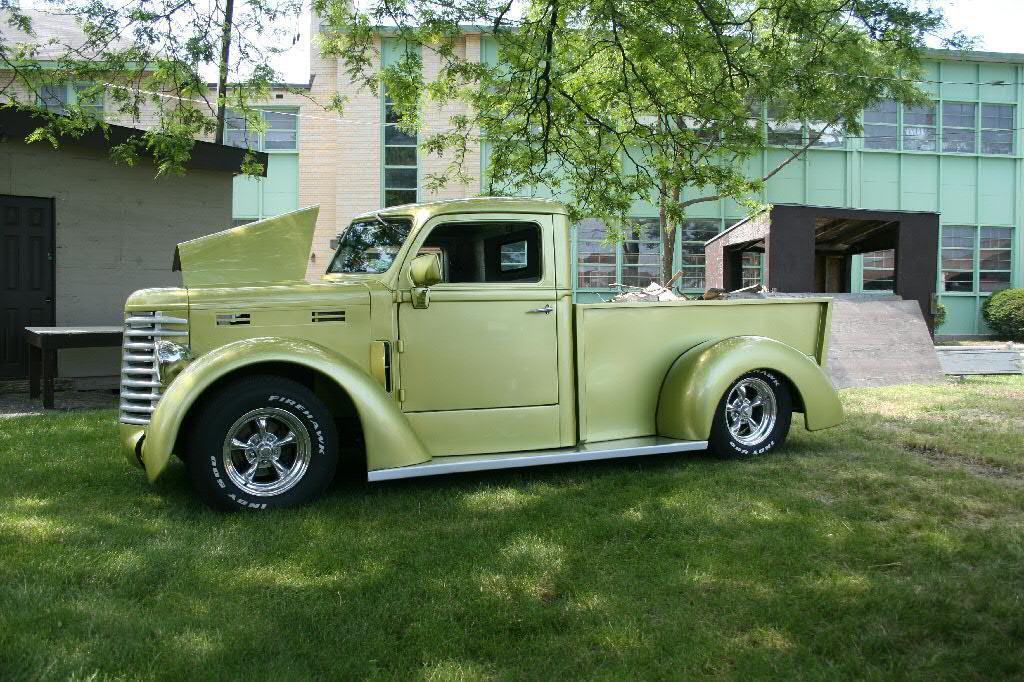Describe this image in one or two sentences. In this picture we can see a vehicle parked on the grass path and behind the vehicle there is a table, shed, buildings, trees and a sky. 